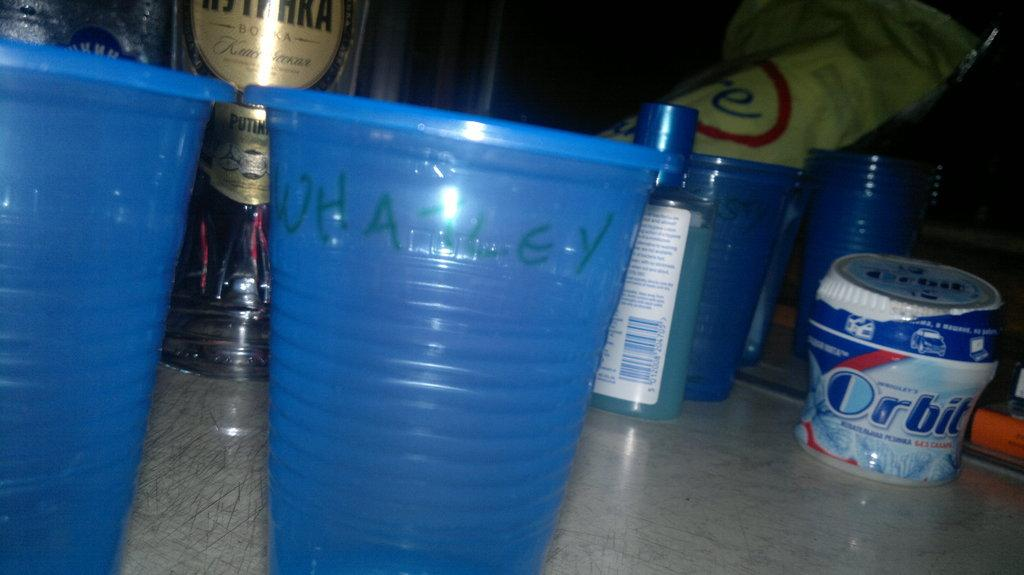<image>
Write a terse but informative summary of the picture. A container of Orbit gum next to some plastic cups. 